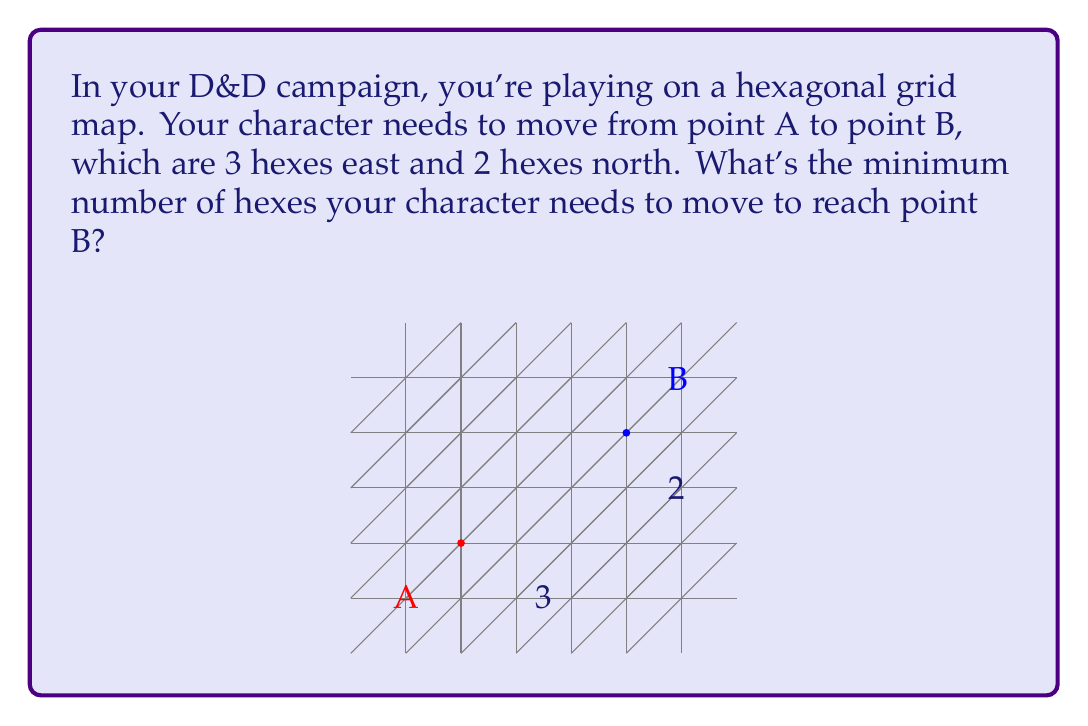Could you help me with this problem? Let's approach this step-by-step:

1) In a hexagonal grid, we can move in six directions: east, northeast, northwest, west, southwest, and southeast.

2) To reach point B from point A, we need to move 3 hexes east and 2 hexes north. However, we can combine these movements using diagonal moves.

3) In a hexagonal grid, moving northeast counts as moving half a hex east and one hex north. Similarly, moving southeast counts as moving half a hex east and one hex south.

4) To optimize our path, we should use as many diagonal moves as possible in the direction of our target.

5) We can move 2 hexes northeast, which will cover:
   $2 \cdot (\frac{1}{2}$ east $+ 1$ north$) = 1$ east $+ 2$ north

6) After these 2 moves, we've covered the entire north distance and 1 out of 3 east distances.

7) We then need to move 2 more hexes directly east to reach point B.

8) Total moves: 2 (northeast) + 2 (east) = 4 moves

This is the minimum number of moves possible to reach point B from point A.
Answer: 4 hexes 